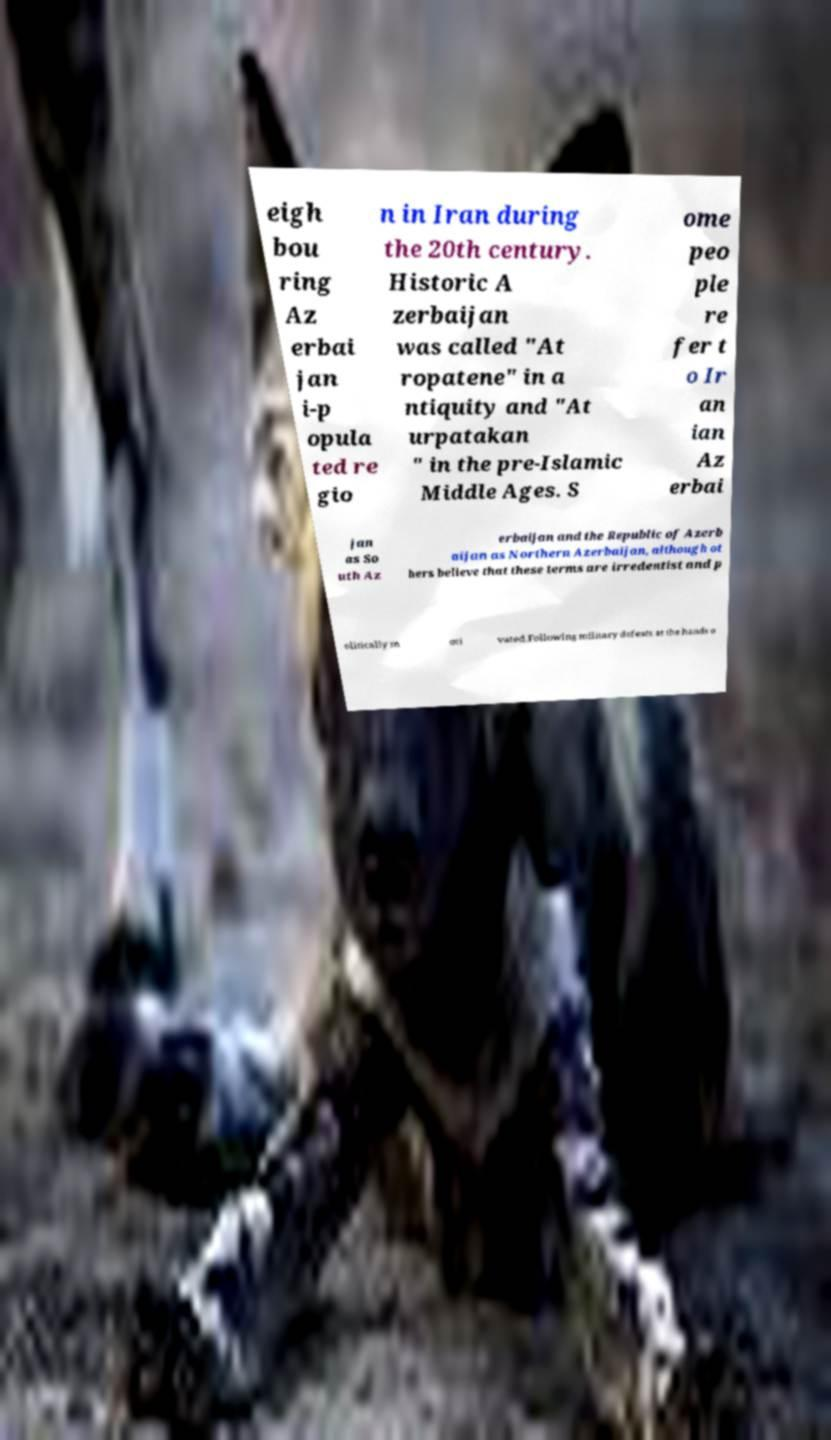Please read and relay the text visible in this image. What does it say? eigh bou ring Az erbai jan i-p opula ted re gio n in Iran during the 20th century. Historic A zerbaijan was called "At ropatene" in a ntiquity and "At urpatakan " in the pre-Islamic Middle Ages. S ome peo ple re fer t o Ir an ian Az erbai jan as So uth Az erbaijan and the Republic of Azerb aijan as Northern Azerbaijan, although ot hers believe that these terms are irredentist and p olitically m oti vated.Following military defeats at the hands o 